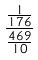Convert formula to latex. <formula><loc_0><loc_0><loc_500><loc_500>\frac { \frac { 1 } { 1 7 6 } } { \frac { 4 6 9 } { 1 0 } }</formula> 